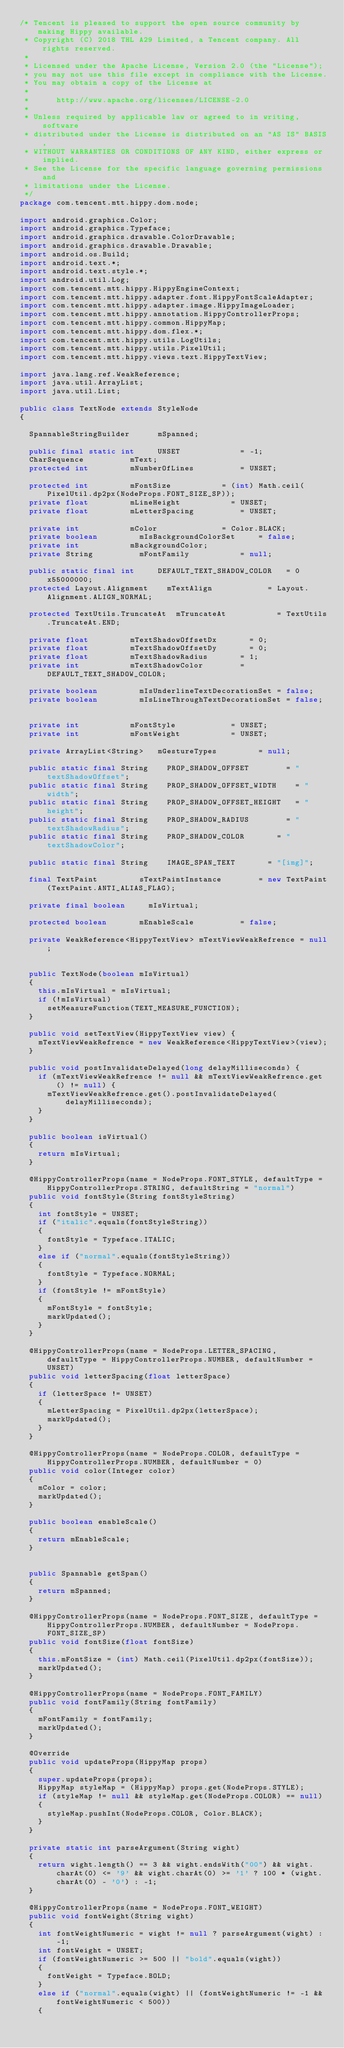Convert code to text. <code><loc_0><loc_0><loc_500><loc_500><_Java_>/* Tencent is pleased to support the open source community by making Hippy available.
 * Copyright (C) 2018 THL A29 Limited, a Tencent company. All rights reserved.
 *
 * Licensed under the Apache License, Version 2.0 (the "License");
 * you may not use this file except in compliance with the License.
 * You may obtain a copy of the License at
 *
 *      http://www.apache.org/licenses/LICENSE-2.0
 *
 * Unless required by applicable law or agreed to in writing, software
 * distributed under the License is distributed on an "AS IS" BASIS,
 * WITHOUT WARRANTIES OR CONDITIONS OF ANY KIND, either express or implied.
 * See the License for the specific language governing permissions and
 * limitations under the License.
 */
package com.tencent.mtt.hippy.dom.node;

import android.graphics.Color;
import android.graphics.Typeface;
import android.graphics.drawable.ColorDrawable;
import android.graphics.drawable.Drawable;
import android.os.Build;
import android.text.*;
import android.text.style.*;
import android.util.Log;
import com.tencent.mtt.hippy.HippyEngineContext;
import com.tencent.mtt.hippy.adapter.font.HippyFontScaleAdapter;
import com.tencent.mtt.hippy.adapter.image.HippyImageLoader;
import com.tencent.mtt.hippy.annotation.HippyControllerProps;
import com.tencent.mtt.hippy.common.HippyMap;
import com.tencent.mtt.hippy.dom.flex.*;
import com.tencent.mtt.hippy.utils.LogUtils;
import com.tencent.mtt.hippy.utils.PixelUtil;
import com.tencent.mtt.hippy.views.text.HippyTextView;

import java.lang.ref.WeakReference;
import java.util.ArrayList;
import java.util.List;

public class TextNode extends StyleNode
{

	SpannableStringBuilder			mSpanned;

	public final static int			UNSET							= -1;
	CharSequence					mText;
	protected int					mNumberOfLines					= UNSET;

	protected int					mFontSize						= (int) Math.ceil(PixelUtil.dp2px(NodeProps.FONT_SIZE_SP));
	private float					mLineHeight						= UNSET;
	private float					mLetterSpacing					= UNSET;

	private int						mColor							= Color.BLACK;
	private boolean					mIsBackgroundColorSet			= false;
	private int						mBackgroundColor;
	private String					mFontFamily						= null;

	public static final int			DEFAULT_TEXT_SHADOW_COLOR		= 0x55000000;
	protected Layout.Alignment		mTextAlign						= Layout.Alignment.ALIGN_NORMAL;

	protected TextUtils.TruncateAt	mTruncateAt						= TextUtils.TruncateAt.END;

	private float					mTextShadowOffsetDx				= 0;
	private float					mTextShadowOffsetDy				= 0;
	private float					mTextShadowRadius				= 1;
	private int						mTextShadowColor				= DEFAULT_TEXT_SHADOW_COLOR;

	private boolean					mIsUnderlineTextDecorationSet	= false;
	private boolean					mIsLineThroughTextDecorationSet	= false;


	private int						mFontStyle						= UNSET;
	private int						mFontWeight						= UNSET;

	private ArrayList<String>		mGestureTypes					= null;

	public static final String		PROP_SHADOW_OFFSET				= "textShadowOffset";
	public static final String		PROP_SHADOW_OFFSET_WIDTH		= "width";
	public static final String		PROP_SHADOW_OFFSET_HEIGHT		= "height";
	public static final String		PROP_SHADOW_RADIUS				= "textShadowRadius";
	public static final String		PROP_SHADOW_COLOR				= "textShadowColor";

	public static final String		IMAGE_SPAN_TEXT				= "[img]";

	final TextPaint					sTextPaintInstance				= new TextPaint(TextPaint.ANTI_ALIAS_FLAG);

	private final boolean			mIsVirtual;

	protected boolean				mEnableScale					= false;

	private WeakReference<HippyTextView> mTextViewWeakRefrence = null;


	public TextNode(boolean mIsVirtual)
	{
		this.mIsVirtual = mIsVirtual;
		if (!mIsVirtual)
			setMeasureFunction(TEXT_MEASURE_FUNCTION);
	}

	public void setTextView(HippyTextView view) {
		mTextViewWeakRefrence = new WeakReference<HippyTextView>(view);
	}
	
  public void postInvalidateDelayed(long delayMilliseconds) {
	  if (mTextViewWeakRefrence != null && mTextViewWeakRefrence.get() != null) {
      mTextViewWeakRefrence.get().postInvalidateDelayed(delayMilliseconds);
    }
  }
  
	public boolean isVirtual()
	{
		return mIsVirtual;
	}

	@HippyControllerProps(name = NodeProps.FONT_STYLE, defaultType = HippyControllerProps.STRING, defaultString = "normal")
	public void fontStyle(String fontStyleString)
	{
		int fontStyle = UNSET;
		if ("italic".equals(fontStyleString))
		{
			fontStyle = Typeface.ITALIC;
		}
		else if ("normal".equals(fontStyleString))
		{
			fontStyle = Typeface.NORMAL;
		}
		if (fontStyle != mFontStyle)
		{
			mFontStyle = fontStyle;
			markUpdated();
		}
	}

	@HippyControllerProps(name = NodeProps.LETTER_SPACING, defaultType = HippyControllerProps.NUMBER, defaultNumber = UNSET)
	public void letterSpacing(float letterSpace)
	{
		if (letterSpace != UNSET)
		{
			mLetterSpacing = PixelUtil.dp2px(letterSpace);
			markUpdated();
		}
	}

	@HippyControllerProps(name = NodeProps.COLOR, defaultType = HippyControllerProps.NUMBER, defaultNumber = 0)
	public void color(Integer color)
	{
		mColor = color;
		markUpdated();
	}

	public boolean enableScale()
	{
		return mEnableScale;
	}


	public Spannable getSpan()
	{
		return mSpanned;
	}

	@HippyControllerProps(name = NodeProps.FONT_SIZE, defaultType = HippyControllerProps.NUMBER, defaultNumber = NodeProps.FONT_SIZE_SP)
	public void fontSize(float fontSize)
	{
		this.mFontSize = (int) Math.ceil(PixelUtil.dp2px(fontSize));
		markUpdated();
	}

	@HippyControllerProps(name = NodeProps.FONT_FAMILY)
	public void fontFamily(String fontFamily)
	{
		mFontFamily = fontFamily;
		markUpdated();
	}

	@Override
	public void updateProps(HippyMap props)
	{
		super.updateProps(props);
		HippyMap styleMap = (HippyMap) props.get(NodeProps.STYLE);
		if (styleMap != null && styleMap.get(NodeProps.COLOR) == null)
		{
			styleMap.pushInt(NodeProps.COLOR, Color.BLACK);
		}
	}

	private static int parseArgument(String wight)
	{
		return wight.length() == 3 && wight.endsWith("00") && wight.charAt(0) <= '9' && wight.charAt(0) >= '1' ? 100 * (wight.charAt(0) - '0') : -1;
	}

	@HippyControllerProps(name = NodeProps.FONT_WEIGHT)
	public void fontWeight(String wight)
	{
		int fontWeightNumeric = wight != null ? parseArgument(wight) : -1;
		int fontWeight = UNSET;
		if (fontWeightNumeric >= 500 || "bold".equals(wight))
		{
			fontWeight = Typeface.BOLD;
		}
		else if ("normal".equals(wight) || (fontWeightNumeric != -1 && fontWeightNumeric < 500))
		{</code> 